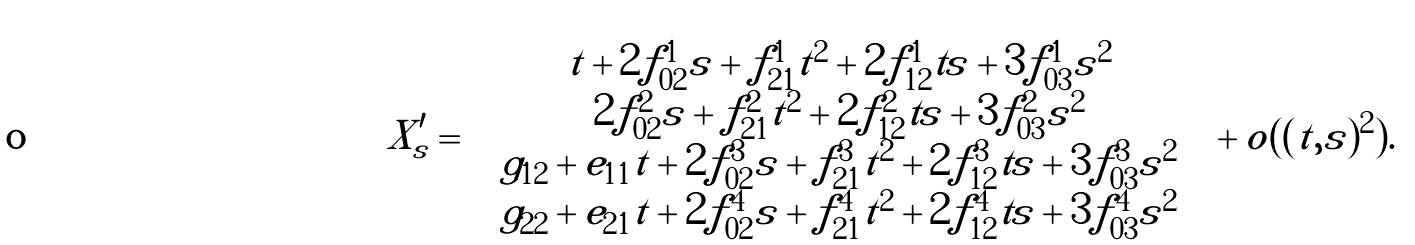Convert formula to latex. <formula><loc_0><loc_0><loc_500><loc_500>X ^ { \prime } _ { s } = \left ( \begin{array} { c } t + 2 f ^ { 1 } _ { 0 2 } s + f ^ { 1 } _ { 2 1 } t ^ { 2 } + 2 f ^ { 1 } _ { 1 2 } t s + 3 f ^ { 1 } _ { 0 3 } s ^ { 2 } \\ 2 f ^ { 2 } _ { 0 2 } s + f ^ { 2 } _ { 2 1 } t ^ { 2 } + 2 f ^ { 2 } _ { 1 2 } t s + 3 f ^ { 2 } _ { 0 3 } s ^ { 2 } \\ g _ { 1 2 } + e _ { 1 1 } t + 2 f ^ { 3 } _ { 0 2 } s + f ^ { 3 } _ { 2 1 } t ^ { 2 } + 2 f ^ { 3 } _ { 1 2 } t s + 3 f ^ { 3 } _ { 0 3 } s ^ { 2 } \\ g _ { 2 2 } + e _ { 2 1 } t + 2 f ^ { 4 } _ { 0 2 } s + f ^ { 4 } _ { 2 1 } t ^ { 2 } + 2 f ^ { 4 } _ { 1 2 } t s + 3 f ^ { 4 } _ { 0 3 } s ^ { 2 } \end{array} \right ) + o ( | ( t , s ) | ^ { 2 } ) .</formula> 